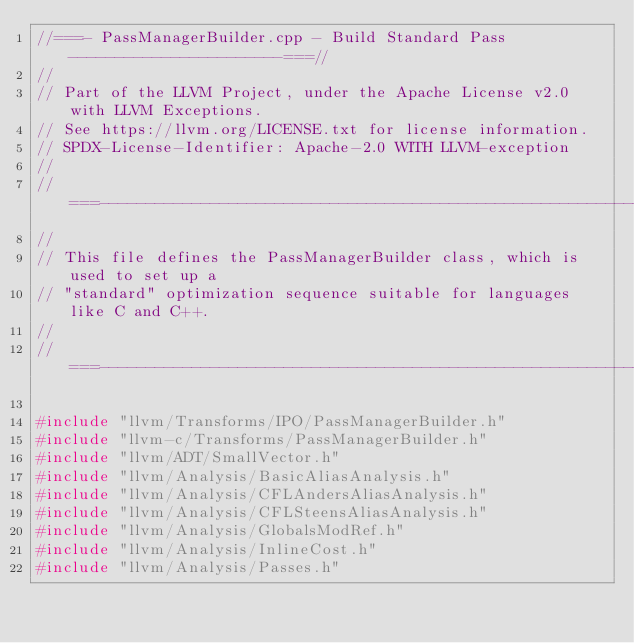Convert code to text. <code><loc_0><loc_0><loc_500><loc_500><_C++_>//===- PassManagerBuilder.cpp - Build Standard Pass -----------------------===//
//
// Part of the LLVM Project, under the Apache License v2.0 with LLVM Exceptions.
// See https://llvm.org/LICENSE.txt for license information.
// SPDX-License-Identifier: Apache-2.0 WITH LLVM-exception
//
//===----------------------------------------------------------------------===//
//
// This file defines the PassManagerBuilder class, which is used to set up a
// "standard" optimization sequence suitable for languages like C and C++.
//
//===----------------------------------------------------------------------===//

#include "llvm/Transforms/IPO/PassManagerBuilder.h"
#include "llvm-c/Transforms/PassManagerBuilder.h"
#include "llvm/ADT/SmallVector.h"
#include "llvm/Analysis/BasicAliasAnalysis.h"
#include "llvm/Analysis/CFLAndersAliasAnalysis.h"
#include "llvm/Analysis/CFLSteensAliasAnalysis.h"
#include "llvm/Analysis/GlobalsModRef.h"
#include "llvm/Analysis/InlineCost.h"
#include "llvm/Analysis/Passes.h"</code> 